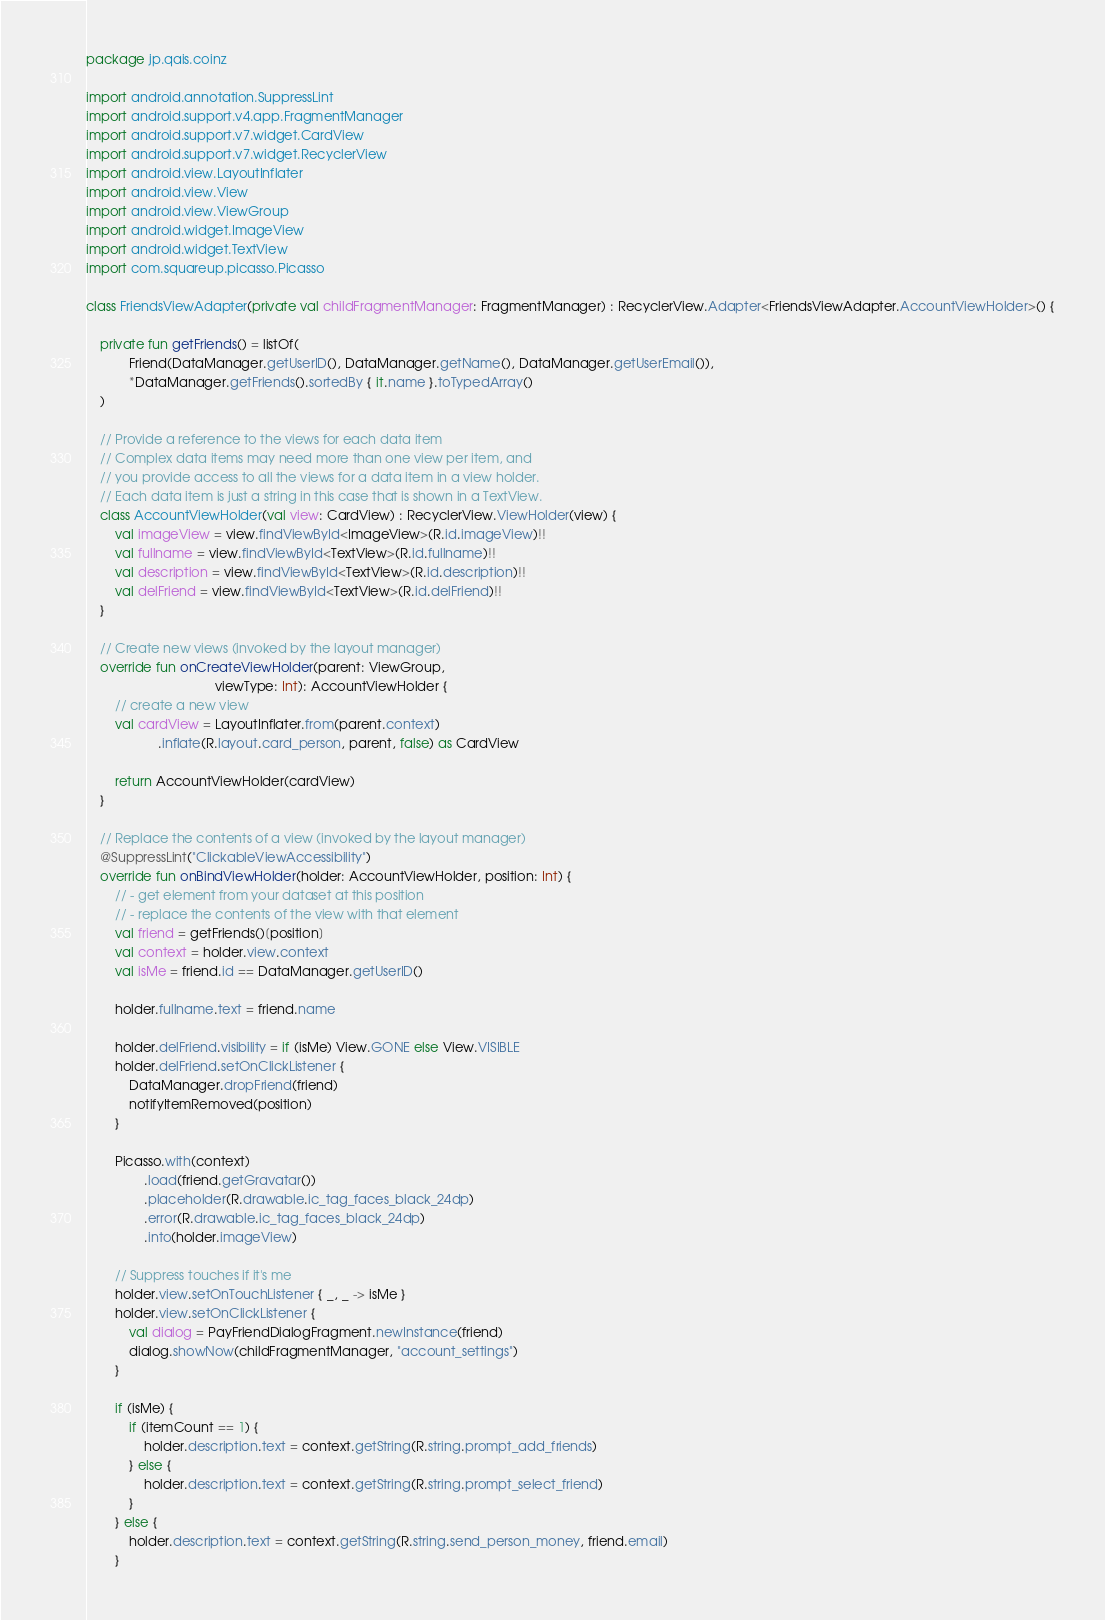Convert code to text. <code><loc_0><loc_0><loc_500><loc_500><_Kotlin_>package jp.qais.coinz

import android.annotation.SuppressLint
import android.support.v4.app.FragmentManager
import android.support.v7.widget.CardView
import android.support.v7.widget.RecyclerView
import android.view.LayoutInflater
import android.view.View
import android.view.ViewGroup
import android.widget.ImageView
import android.widget.TextView
import com.squareup.picasso.Picasso

class FriendsViewAdapter(private val childFragmentManager: FragmentManager) : RecyclerView.Adapter<FriendsViewAdapter.AccountViewHolder>() {

    private fun getFriends() = listOf(
            Friend(DataManager.getUserID(), DataManager.getName(), DataManager.getUserEmail()),
            *DataManager.getFriends().sortedBy { it.name }.toTypedArray()
    )

    // Provide a reference to the views for each data item
    // Complex data items may need more than one view per item, and
    // you provide access to all the views for a data item in a view holder.
    // Each data item is just a string in this case that is shown in a TextView.
    class AccountViewHolder(val view: CardView) : RecyclerView.ViewHolder(view) {
        val imageView = view.findViewById<ImageView>(R.id.imageView)!!
        val fullname = view.findViewById<TextView>(R.id.fullname)!!
        val description = view.findViewById<TextView>(R.id.description)!!
        val delFriend = view.findViewById<TextView>(R.id.delFriend)!!
    }

    // Create new views (invoked by the layout manager)
    override fun onCreateViewHolder(parent: ViewGroup,
                                    viewType: Int): AccountViewHolder {
        // create a new view
        val cardView = LayoutInflater.from(parent.context)
                    .inflate(R.layout.card_person, parent, false) as CardView

        return AccountViewHolder(cardView)
    }

    // Replace the contents of a view (invoked by the layout manager)
    @SuppressLint("ClickableViewAccessibility")
    override fun onBindViewHolder(holder: AccountViewHolder, position: Int) {
        // - get element from your dataset at this position
        // - replace the contents of the view with that element
        val friend = getFriends()[position]
        val context = holder.view.context
        val isMe = friend.id == DataManager.getUserID()

        holder.fullname.text = friend.name

        holder.delFriend.visibility = if (isMe) View.GONE else View.VISIBLE
        holder.delFriend.setOnClickListener {
            DataManager.dropFriend(friend)
            notifyItemRemoved(position)
        }

        Picasso.with(context)
                .load(friend.getGravatar())
                .placeholder(R.drawable.ic_tag_faces_black_24dp)
                .error(R.drawable.ic_tag_faces_black_24dp)
                .into(holder.imageView)

        // Suppress touches if it's me
        holder.view.setOnTouchListener { _, _ -> isMe }
        holder.view.setOnClickListener {
            val dialog = PayFriendDialogFragment.newInstance(friend)
            dialog.showNow(childFragmentManager, "account_settings")
        }

        if (isMe) {
            if (itemCount == 1) {
                holder.description.text = context.getString(R.string.prompt_add_friends)
            } else {
                holder.description.text = context.getString(R.string.prompt_select_friend)
            }
        } else {
            holder.description.text = context.getString(R.string.send_person_money, friend.email)
        }</code> 